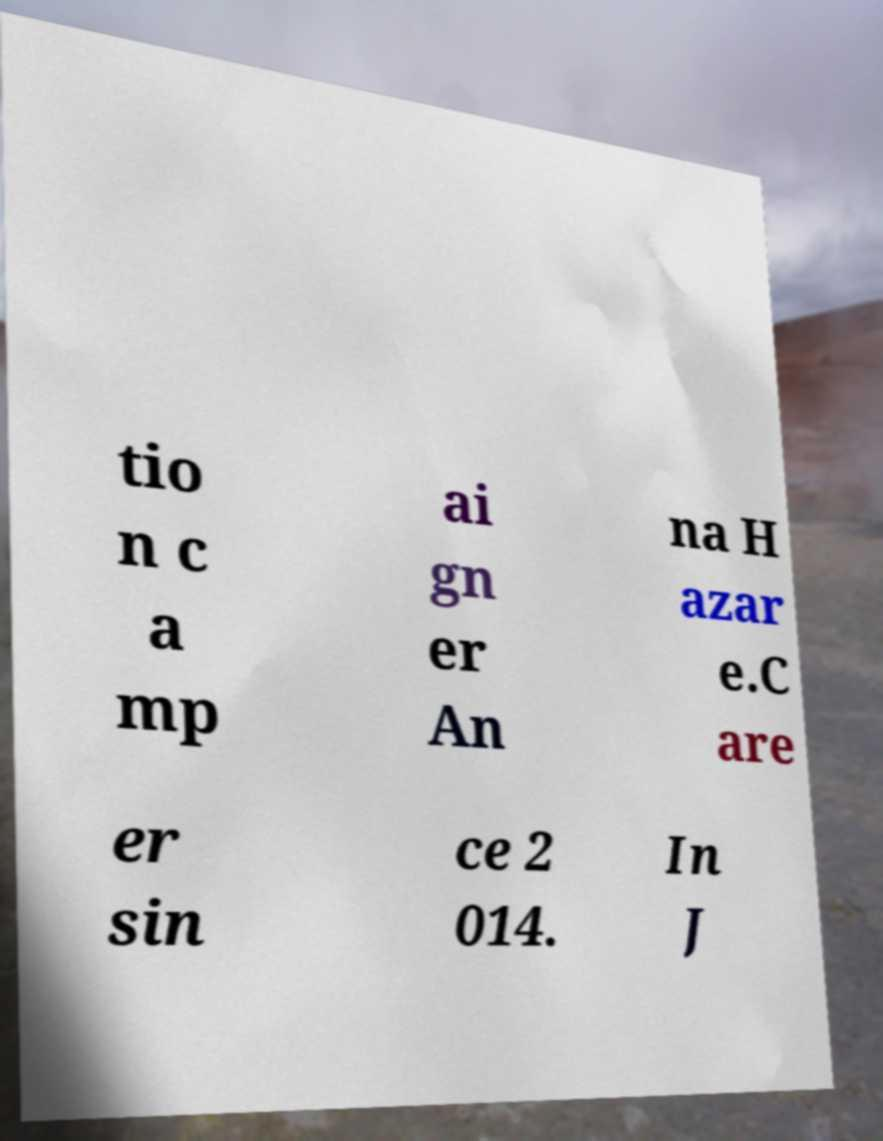Could you assist in decoding the text presented in this image and type it out clearly? tio n c a mp ai gn er An na H azar e.C are er sin ce 2 014. In J 